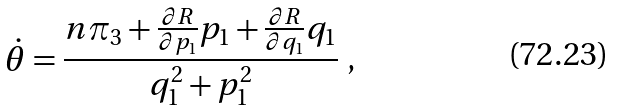Convert formula to latex. <formula><loc_0><loc_0><loc_500><loc_500>\dot { \theta } = \frac { n \pi _ { 3 } + \frac { \partial R } { \partial p _ { 1 } } p _ { 1 } + \frac { \partial R } { \partial q _ { 1 } } q _ { 1 } } { q _ { 1 } ^ { 2 } + p _ { 1 } ^ { 2 } } \ ,</formula> 